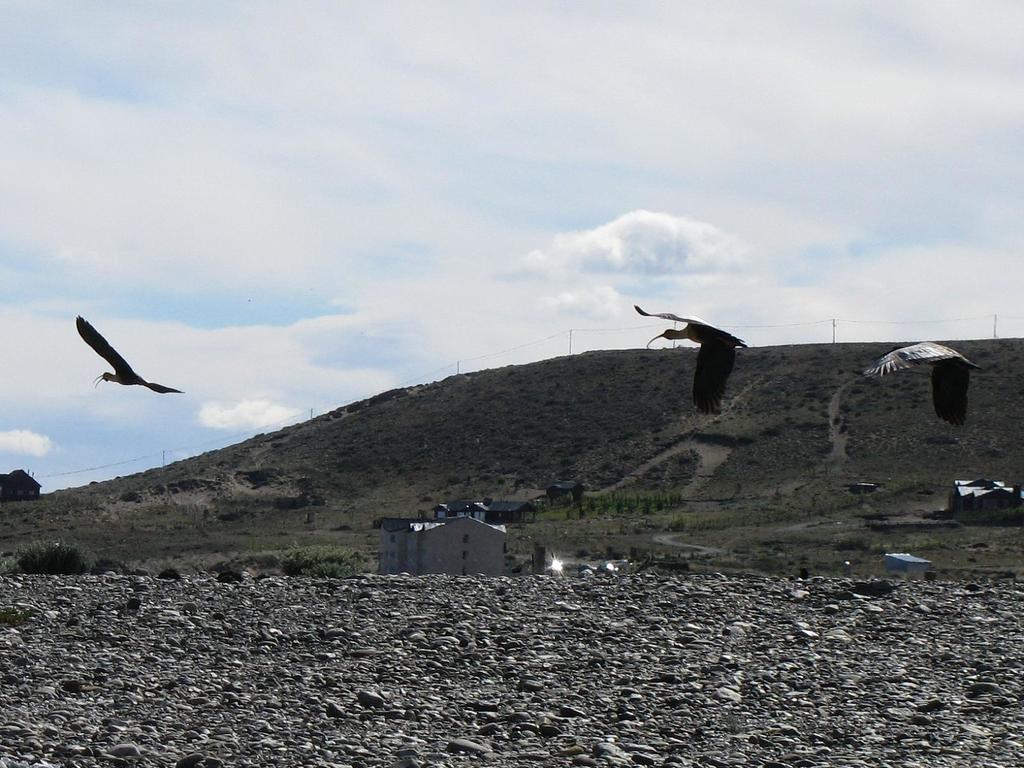Describe this image in one or two sentences. This image consists of three birds flying in the air. At the bottom, there are many rocks on the ground. In the front, we can see houses. In the background, there is a mountain. At the top, there are clouds in the sky. 